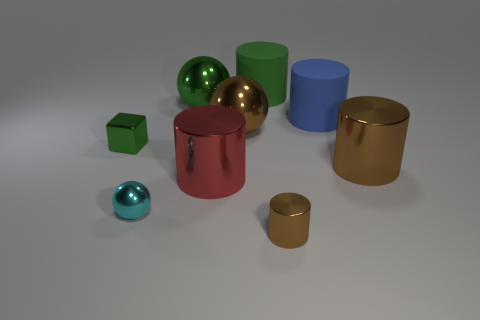There is a cyan object that is made of the same material as the tiny green object; what is its size?
Your answer should be very brief. Small. Are there any green blocks right of the green ball?
Ensure brevity in your answer.  No. Is the shape of the tiny cyan object the same as the big green shiny object?
Your answer should be compact. Yes. There is a brown metal object to the left of the brown object in front of the small cyan shiny ball that is on the right side of the tiny green metal thing; how big is it?
Keep it short and to the point. Large. What material is the small brown thing?
Keep it short and to the point. Metal. Does the cyan metal object have the same shape as the green metal object that is to the right of the green cube?
Offer a terse response. Yes. There is a brown object that is behind the green block that is behind the shiny sphere that is in front of the red shiny cylinder; what is its material?
Your answer should be compact. Metal. How many big brown shiny blocks are there?
Provide a succinct answer. 0. What number of cyan objects are either metal spheres or large metallic objects?
Make the answer very short. 1. How many other things are there of the same shape as the small green object?
Offer a terse response. 0. 